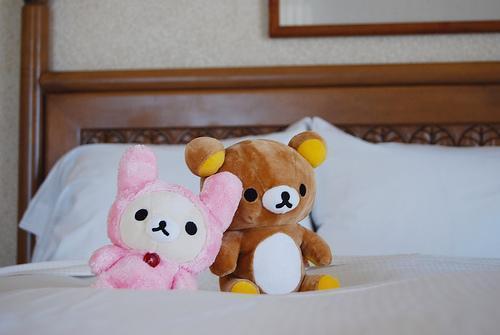How many pillows are on the bed?
Give a very brief answer. 2. How many teddy bears are in the picture?
Give a very brief answer. 2. 